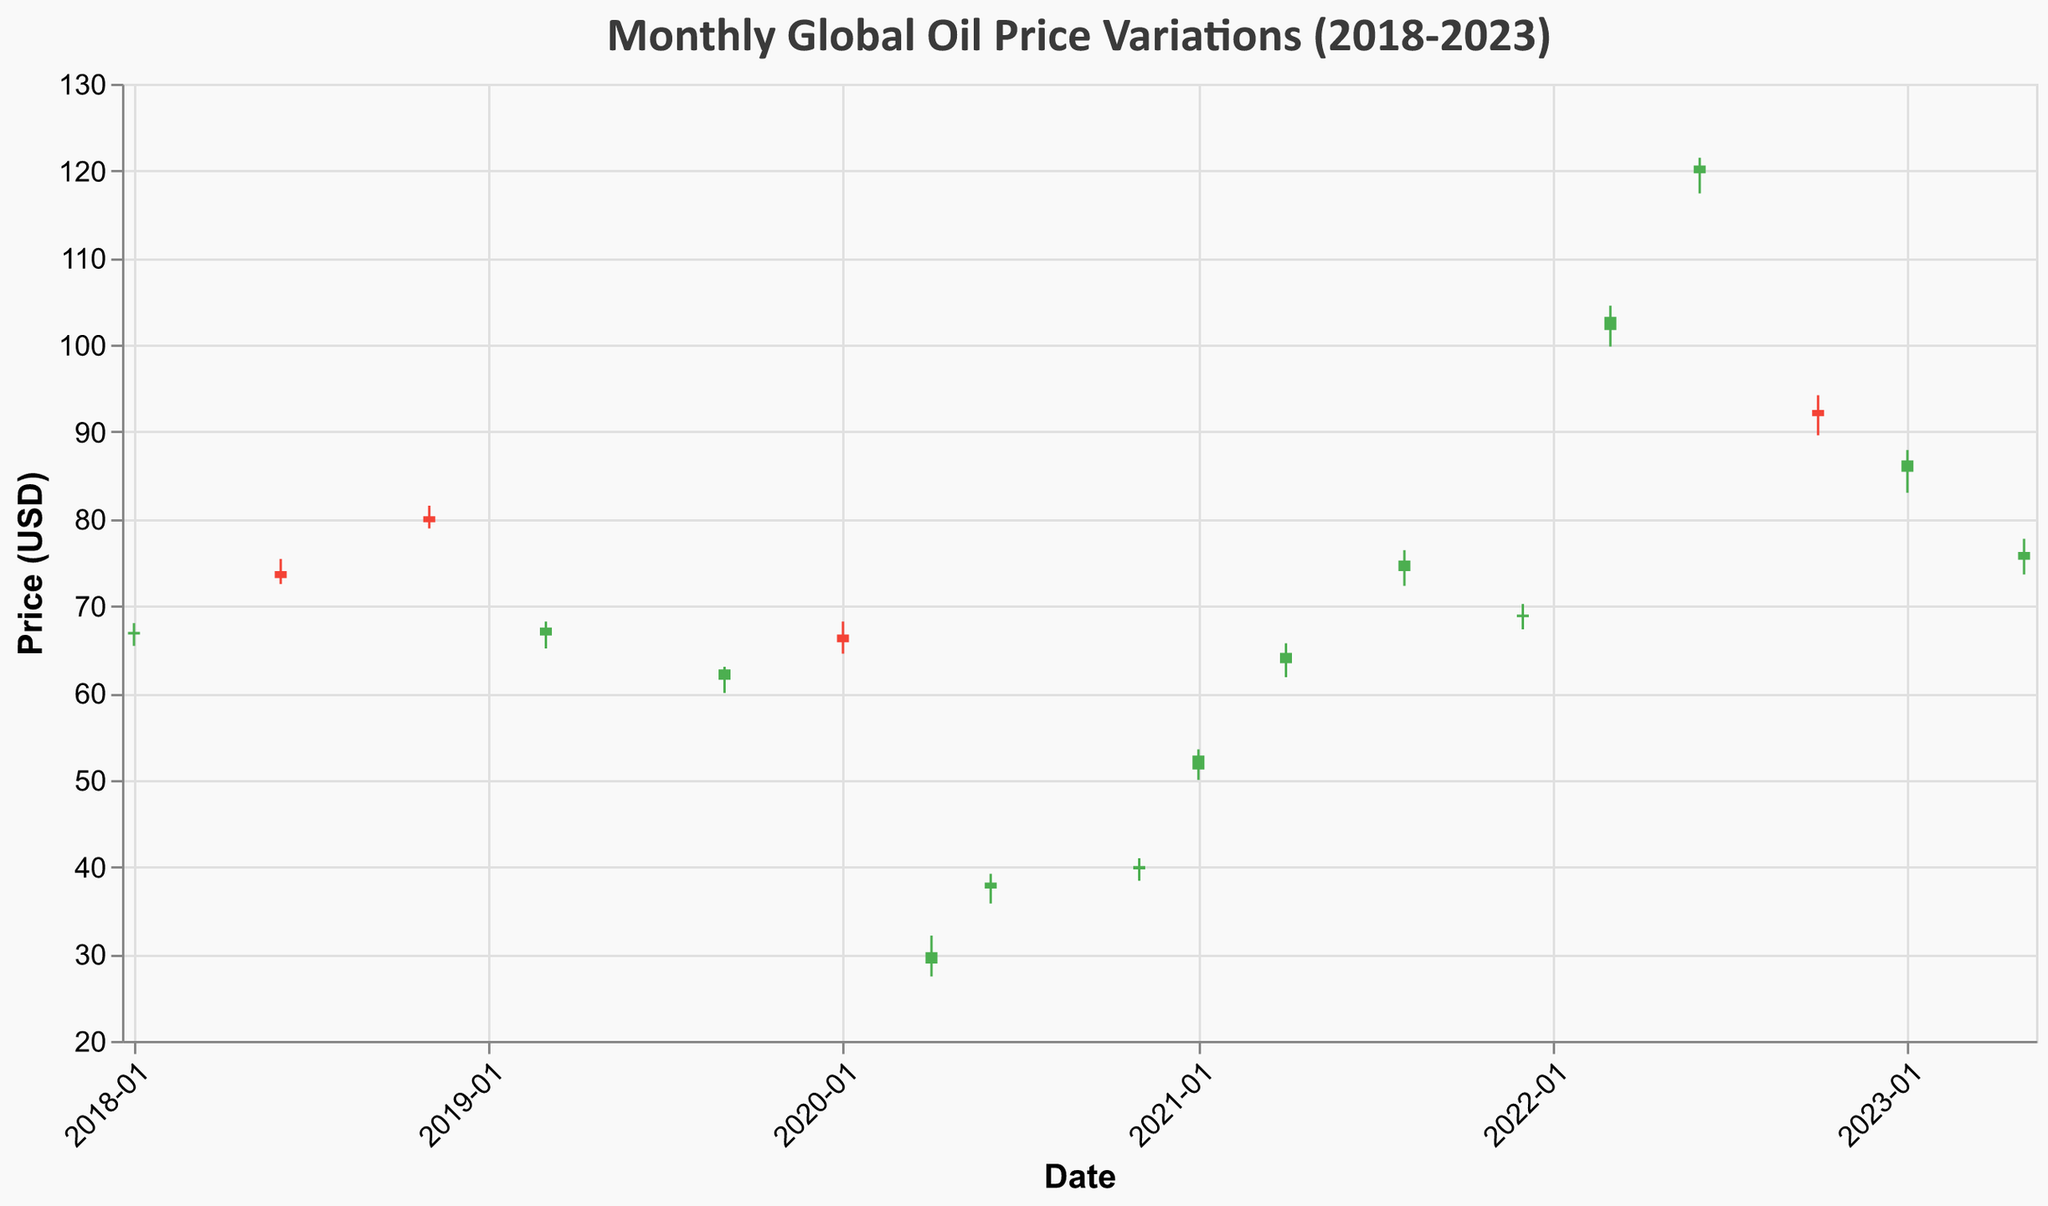What is the title of the figure? The title is usually found at the top, formatted in a larger and bold font. It provides a summary of what the figure represents. In this case, the title is "Monthly Global Oil Price Variations (2018-2023)".
Answer: Monthly Global Oil Price Variations (2018-2023) Which event corresponds to the highest oil price in the dataset? Examine the bars representing the highs along the y-axis. The highest bar corresponds to the EU ban on Russian oil in June 2022.
Answer: EU Ban on Russian Oil What was the closing oil price during the COVID-19 Pandemic Impact in April 2020? Locate the event "COVID-19 Pandemic Impact" on the x-axis (April 2020), then check the corresponding closing price indicated by the top of the candlestick bar.
Answer: 30.20 During the Russia-Ukraine Conflict in March 2022, did the oil price close higher or lower than it opened? For March 2022, observe the color of the candlestick. If it is green, it closed higher; if red, it closed lower. Here, it's green.
Answer: Higher Compare the opening and closing prices during the US-Iran tensions spike in January 2020. What was the difference? Identify the January 2020 data, then subtract the opening price (66.70) from the closing price (65.80). The calculation is 65.80 - 66.70.
Answer: -0.90 Which event saw the largest difference between the high and low oil prices? Look at the length of the vertical lines (wicks) of each candlestick. The longer the line, the larger the difference. The largest difference appears in the EU Ban on Russian Oil in June 2022.
Answer: EU Ban on Russian Oil What's the average closing price for the events related to the US-China trade tensions and war in 2018 and 2019? Identify the closing prices for January 2018 (67.00) and March 2019 (67.50). Calculate the average: (67.00 + 67.50) / 2.
Answer: 67.25 Of all the events listed, which one had the lowest opening price? Locate the event with the smallest value on the opening price scale. The lowest opening price occurred in April 2020 during the COVID-19 Pandemic Impact (28.90).
Answer: COVID-19 Pandemic Impact How did the oil prices react to China reopening its economy after lockdowns in January 2023? Were the prices overall higher or lower than the previous month? Compare January 2023's close (86.70) with the previous month, which is October 2022 (91.80). The average of January 2023 is lower.
Answer: Lower 